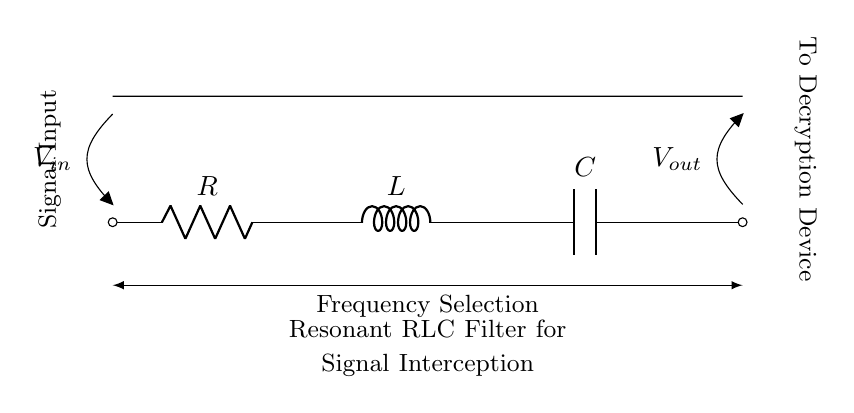What is the voltage input in this circuit? The voltage input, labeled as \( V_{in} \), is indicated at the left side of the circuit diagram, where the signal enters the system.
Answer: V_in What components are present in this circuit? The circuit contains three components: a resistor, an inductor, and a capacitor, as labeled R, L, and C respectively in the diagram.
Answer: Resistor, Inductor, Capacitor What type of filter does this circuit represent? The circuit functions as a resonant RLC filter, which is explicitly stated in the label below the components, indicating its purpose for signal interception.
Answer: Resonant RLC filter What is the direction of current flow? Current flows from the input voltage source to the output, moving through the resistor, inductor, and capacitor in series as shown by the circuit layout.
Answer: Left to right Which component primarily affects frequency selection? The combination of R, L, and C determines the frequency response of this circuit, but mainly the inductor and capacitor create resonance.
Answer: Inductor and Capacitor Why does this circuit intercept signals? The resonant RLC filter is designed to select certain frequencies from a signal input and attenuate others, making it useful for interception in decryption devices as described in the circuit.
Answer: Resonance for frequency selection 